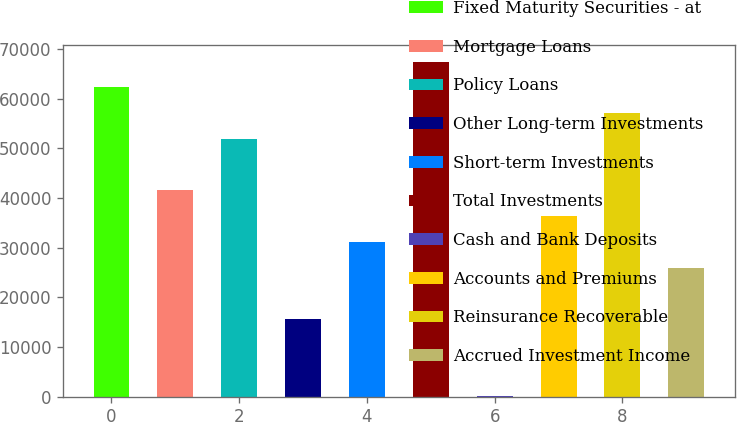<chart> <loc_0><loc_0><loc_500><loc_500><bar_chart><fcel>Fixed Maturity Securities - at<fcel>Mortgage Loans<fcel>Policy Loans<fcel>Other Long-term Investments<fcel>Short-term Investments<fcel>Total Investments<fcel>Cash and Bank Deposits<fcel>Accounts and Premiums<fcel>Reinsurance Recoverable<fcel>Accrued Investment Income<nl><fcel>62270.3<fcel>41539.3<fcel>51904.8<fcel>15625.5<fcel>31173.8<fcel>67453.1<fcel>77.3<fcel>36356.6<fcel>57087.6<fcel>25991<nl></chart> 